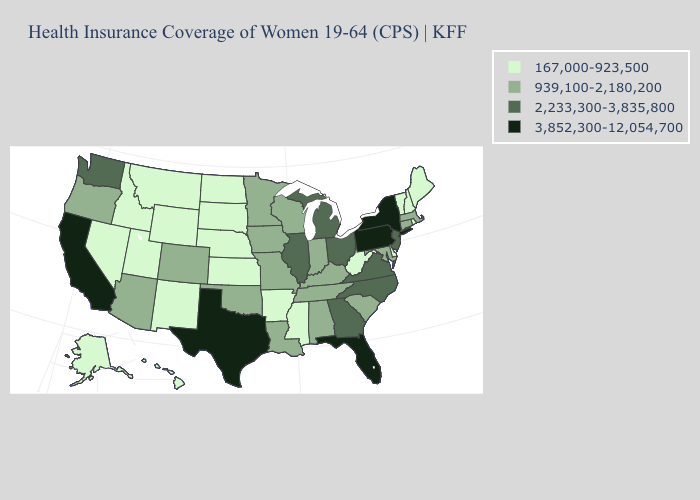Name the states that have a value in the range 939,100-2,180,200?
Give a very brief answer. Alabama, Arizona, Colorado, Connecticut, Indiana, Iowa, Kentucky, Louisiana, Maryland, Massachusetts, Minnesota, Missouri, Oklahoma, Oregon, South Carolina, Tennessee, Wisconsin. What is the value of Nevada?
Short answer required. 167,000-923,500. Which states hav the highest value in the Northeast?
Be succinct. New York, Pennsylvania. Among the states that border Pennsylvania , which have the highest value?
Concise answer only. New York. Which states have the lowest value in the Northeast?
Be succinct. Maine, New Hampshire, Rhode Island, Vermont. Does the map have missing data?
Quick response, please. No. Does Iowa have a higher value than Massachusetts?
Short answer required. No. What is the value of Indiana?
Give a very brief answer. 939,100-2,180,200. Name the states that have a value in the range 3,852,300-12,054,700?
Quick response, please. California, Florida, New York, Pennsylvania, Texas. Name the states that have a value in the range 939,100-2,180,200?
Short answer required. Alabama, Arizona, Colorado, Connecticut, Indiana, Iowa, Kentucky, Louisiana, Maryland, Massachusetts, Minnesota, Missouri, Oklahoma, Oregon, South Carolina, Tennessee, Wisconsin. What is the lowest value in the South?
Answer briefly. 167,000-923,500. Which states hav the highest value in the South?
Answer briefly. Florida, Texas. Among the states that border Connecticut , which have the lowest value?
Keep it brief. Rhode Island. Does Massachusetts have the highest value in the USA?
Concise answer only. No. Which states have the lowest value in the Northeast?
Write a very short answer. Maine, New Hampshire, Rhode Island, Vermont. 